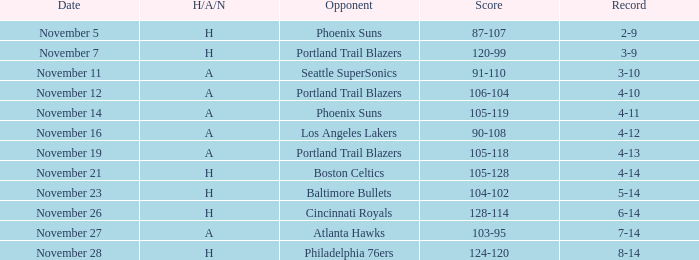When was the score recorded as 105-128? November 21. 